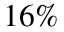Convert formula to latex. <formula><loc_0><loc_0><loc_500><loc_500>1 6 \%</formula> 